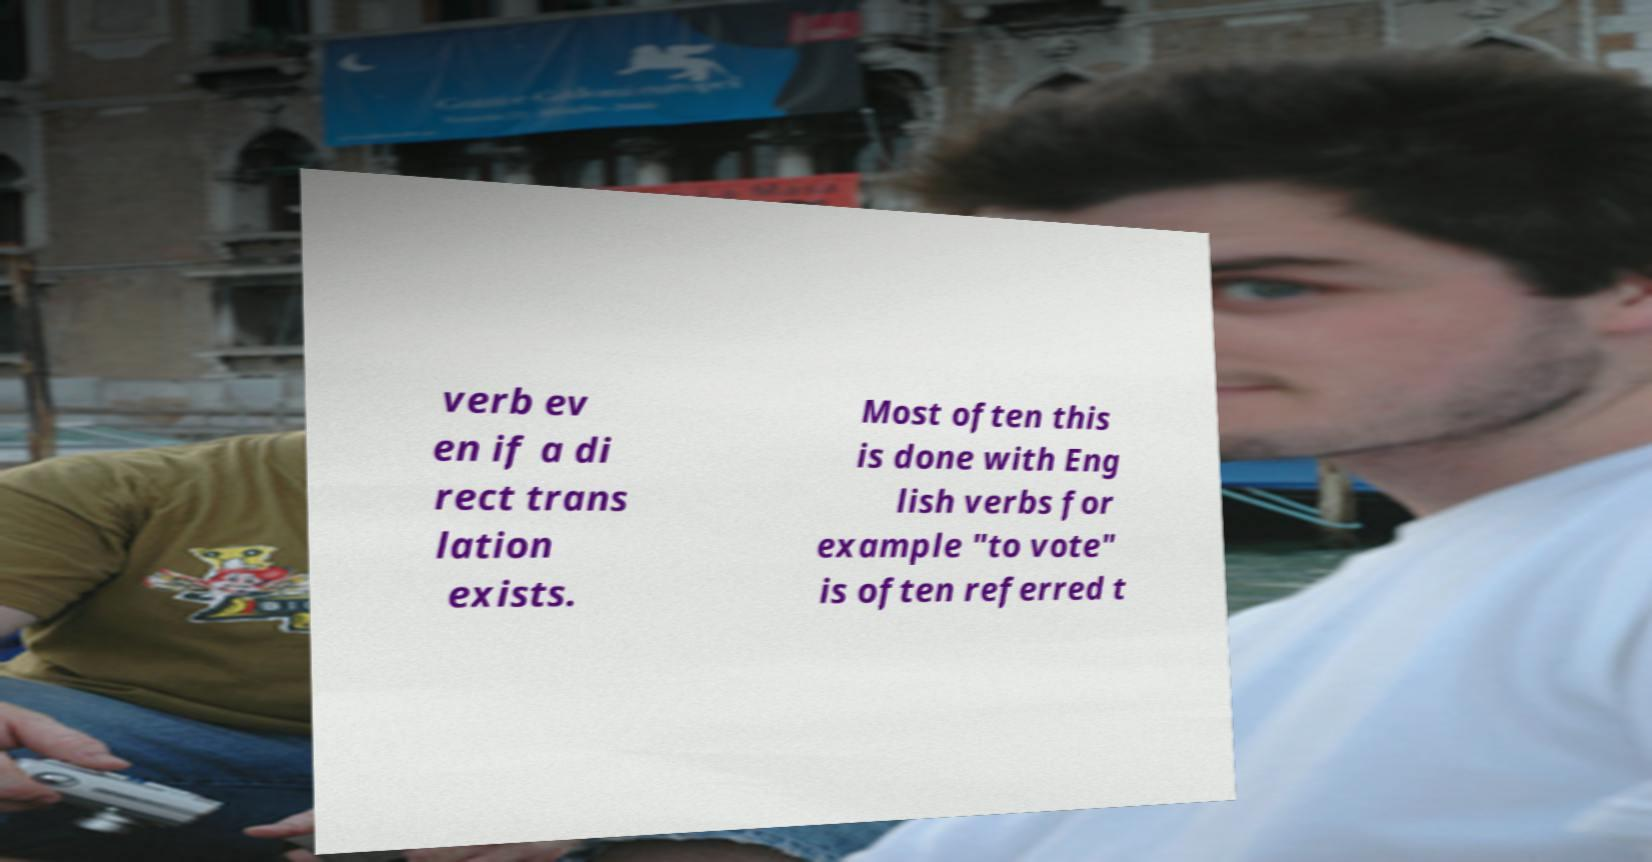What messages or text are displayed in this image? I need them in a readable, typed format. verb ev en if a di rect trans lation exists. Most often this is done with Eng lish verbs for example "to vote" is often referred t 